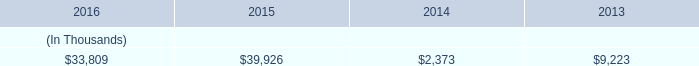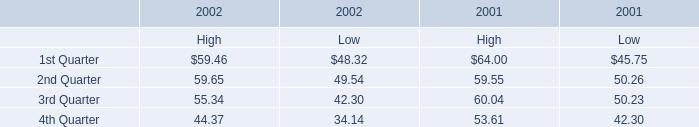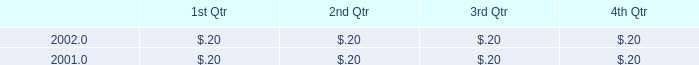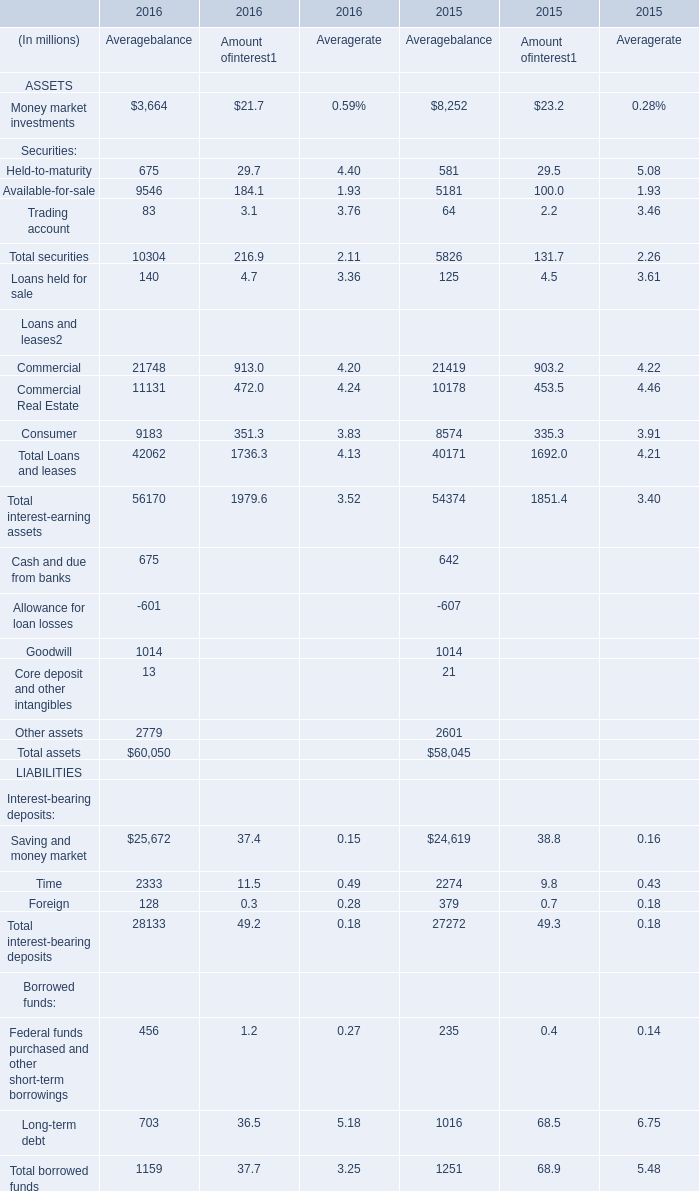What is the sum of securities in the range of 100 and 10000 in 2016 for average balance? (in million) 
Computations: (675 + 9546)
Answer: 10221.0. 